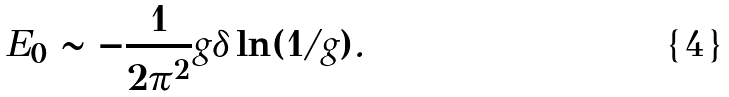<formula> <loc_0><loc_0><loc_500><loc_500>E _ { 0 } \sim - \frac { 1 } { 2 \pi ^ { 2 } } g \delta \ln ( 1 / g ) .</formula> 